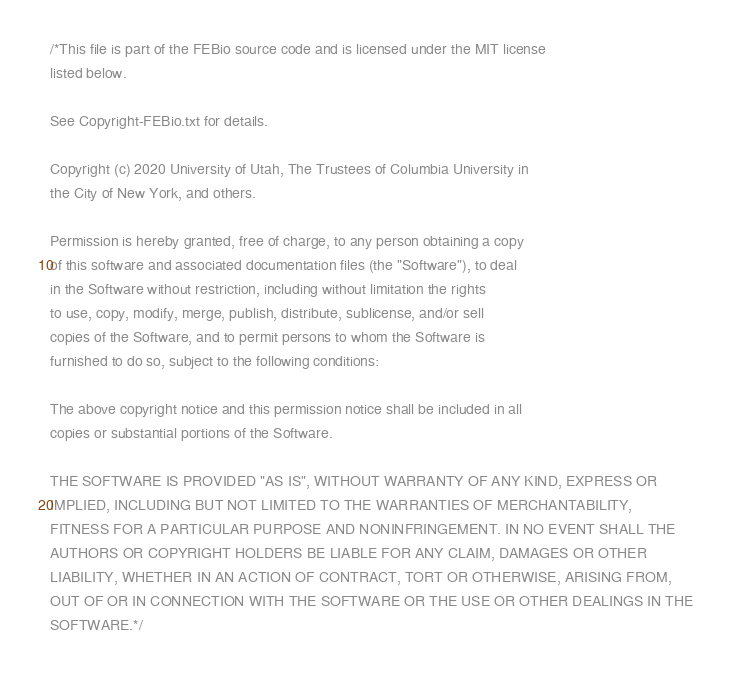<code> <loc_0><loc_0><loc_500><loc_500><_C++_>/*This file is part of the FEBio source code and is licensed under the MIT license
listed below.

See Copyright-FEBio.txt for details.

Copyright (c) 2020 University of Utah, The Trustees of Columbia University in 
the City of New York, and others.

Permission is hereby granted, free of charge, to any person obtaining a copy
of this software and associated documentation files (the "Software"), to deal
in the Software without restriction, including without limitation the rights
to use, copy, modify, merge, publish, distribute, sublicense, and/or sell
copies of the Software, and to permit persons to whom the Software is
furnished to do so, subject to the following conditions:

The above copyright notice and this permission notice shall be included in all
copies or substantial portions of the Software.

THE SOFTWARE IS PROVIDED "AS IS", WITHOUT WARRANTY OF ANY KIND, EXPRESS OR
IMPLIED, INCLUDING BUT NOT LIMITED TO THE WARRANTIES OF MERCHANTABILITY,
FITNESS FOR A PARTICULAR PURPOSE AND NONINFRINGEMENT. IN NO EVENT SHALL THE
AUTHORS OR COPYRIGHT HOLDERS BE LIABLE FOR ANY CLAIM, DAMAGES OR OTHER
LIABILITY, WHETHER IN AN ACTION OF CONTRACT, TORT OR OTHERWISE, ARISING FROM,
OUT OF OR IN CONNECTION WITH THE SOFTWARE OR THE USE OR OTHER DEALINGS IN THE
SOFTWARE.*/


</code> 